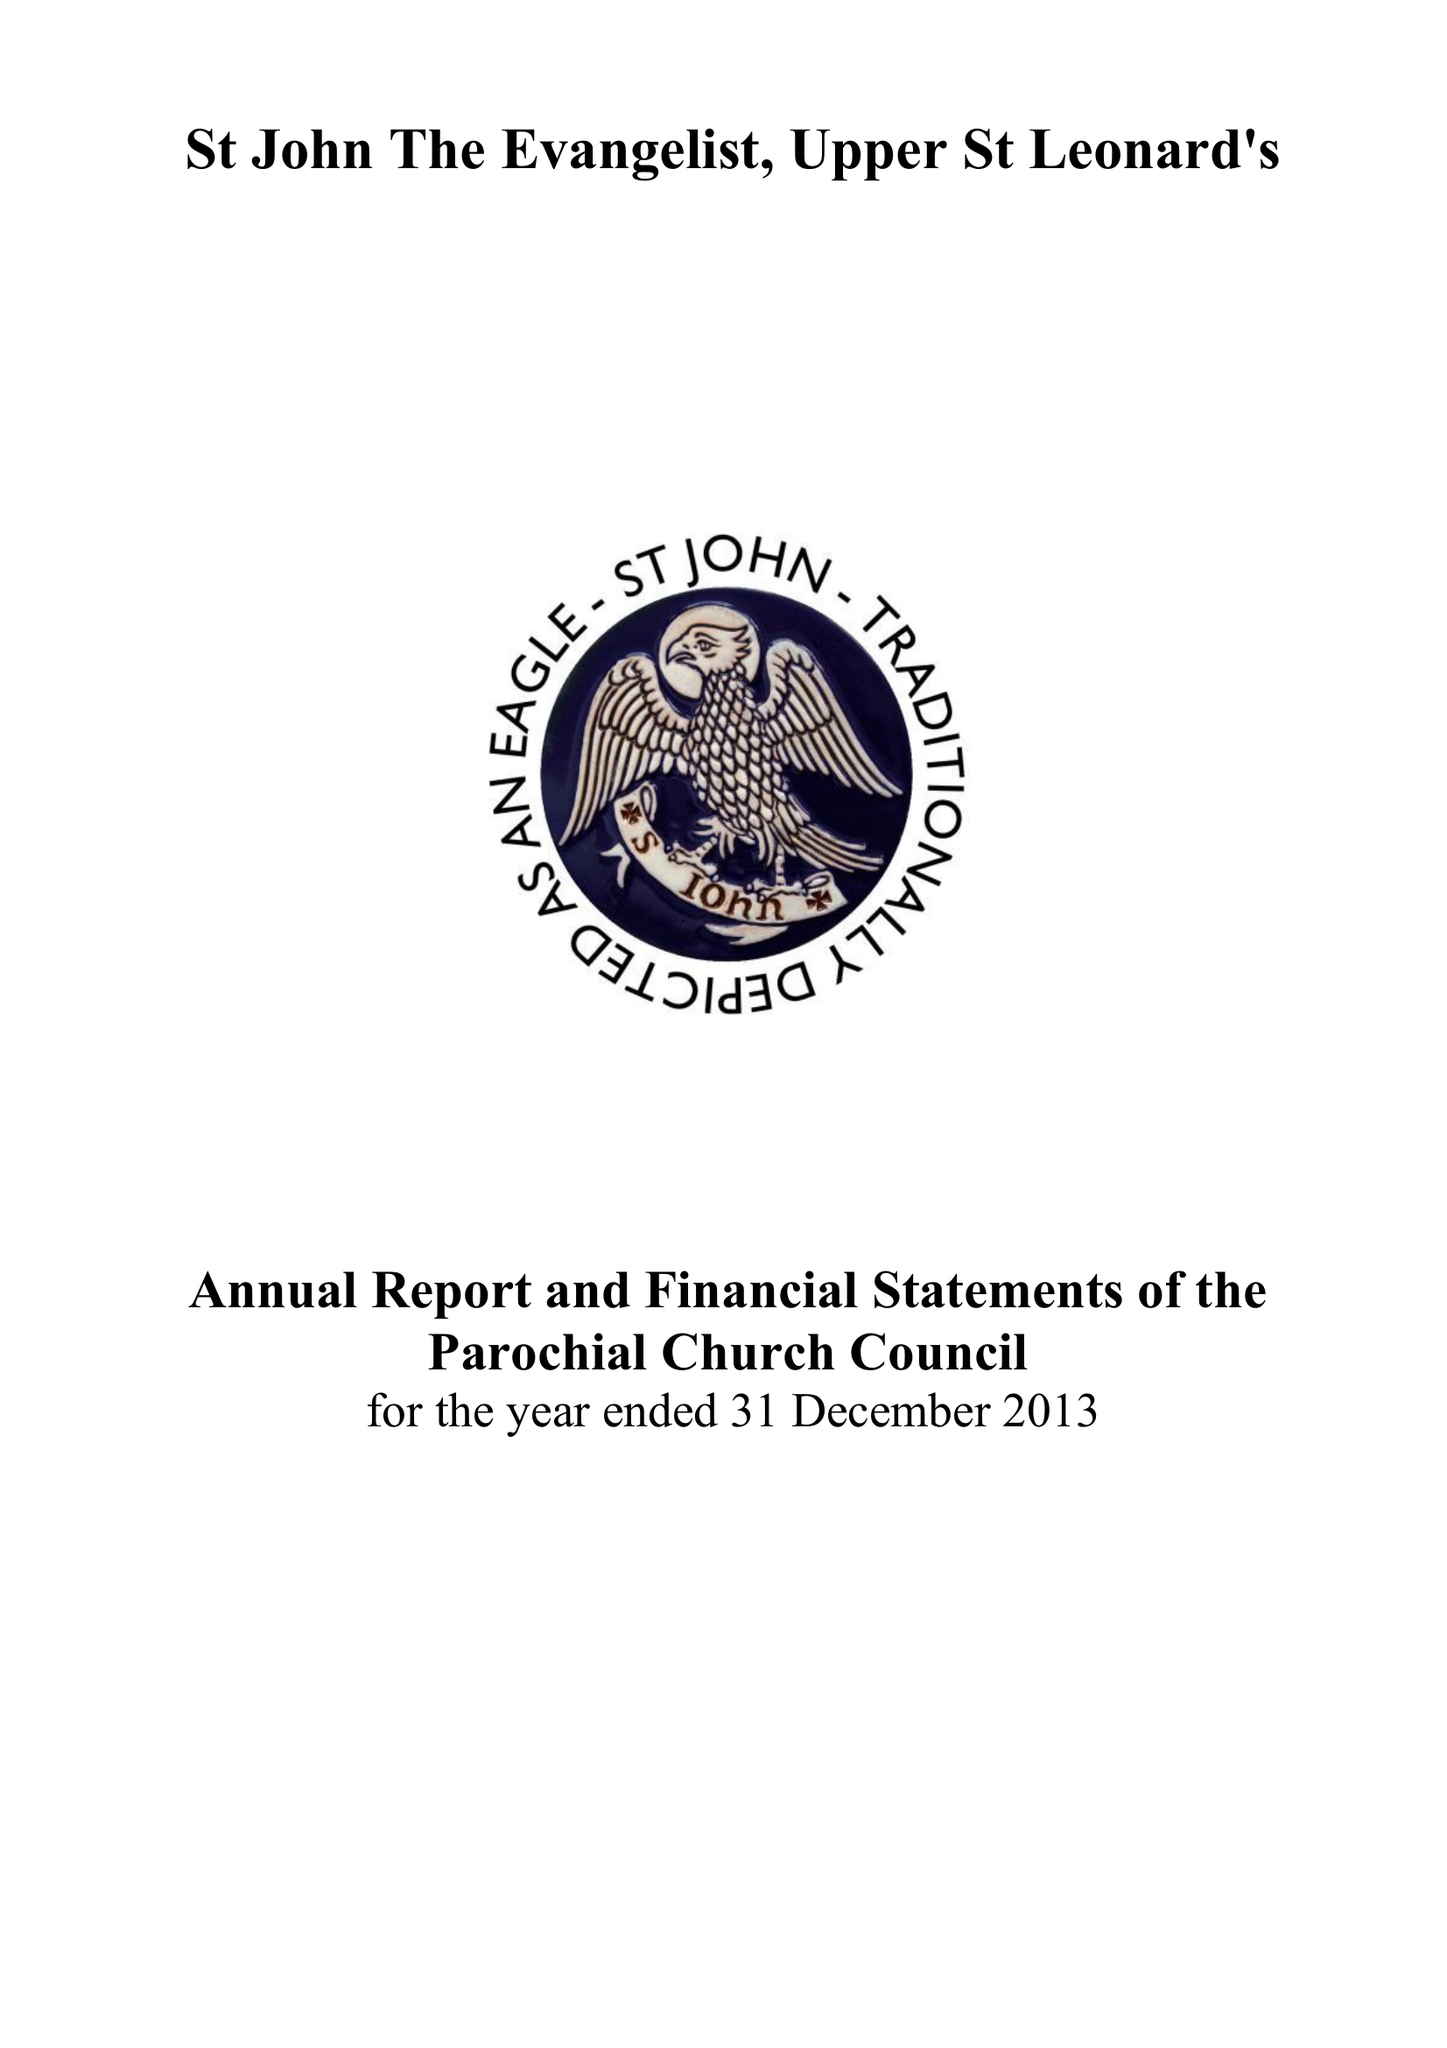What is the value for the address__post_town?
Answer the question using a single word or phrase. ST. LEONARDS-ON-SEA 